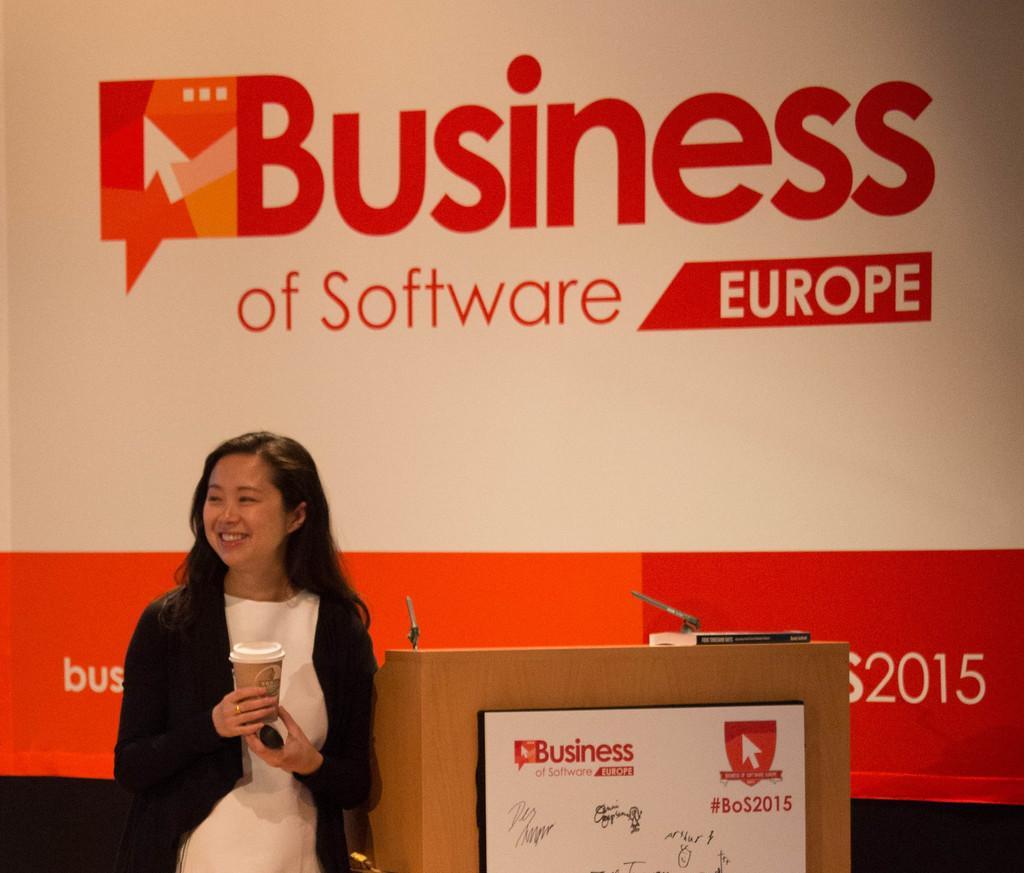Can you describe this image briefly? In this image we can see there is a girl standing and holding an object, beside her there is a table. On the table there is a book. In the background there is a banner with some text. 